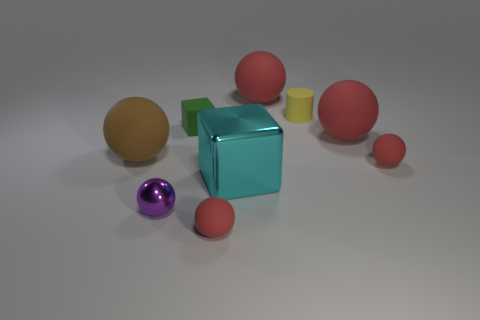What number of large red matte objects are the same shape as the big cyan thing?
Your answer should be very brief. 0. There is a cube that is behind the brown matte thing; does it have the same color as the matte object that is in front of the purple metallic object?
Make the answer very short. No. What is the material of the green object that is the same size as the purple shiny sphere?
Your answer should be very brief. Rubber. Is there a purple metal sphere that has the same size as the green rubber cube?
Provide a succinct answer. Yes. Are there fewer things that are on the left side of the brown matte sphere than cubes?
Offer a very short reply. Yes. Is the number of yellow rubber cylinders in front of the cyan metal cube less than the number of tiny green blocks right of the green thing?
Keep it short and to the point. No. How many cylinders are either large brown objects or green objects?
Your response must be concise. 0. Is the small red sphere behind the small purple metal sphere made of the same material as the big sphere that is behind the tiny green object?
Your response must be concise. Yes. The green matte thing that is the same size as the yellow thing is what shape?
Offer a very short reply. Cube. What number of other objects are there of the same color as the metal block?
Keep it short and to the point. 0. 